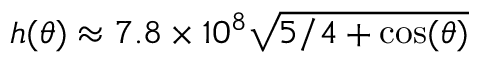Convert formula to latex. <formula><loc_0><loc_0><loc_500><loc_500>h ( \theta ) \approx 7 . 8 \times 1 0 ^ { 8 } \sqrt { 5 / 4 + \cos ( \theta ) }</formula> 